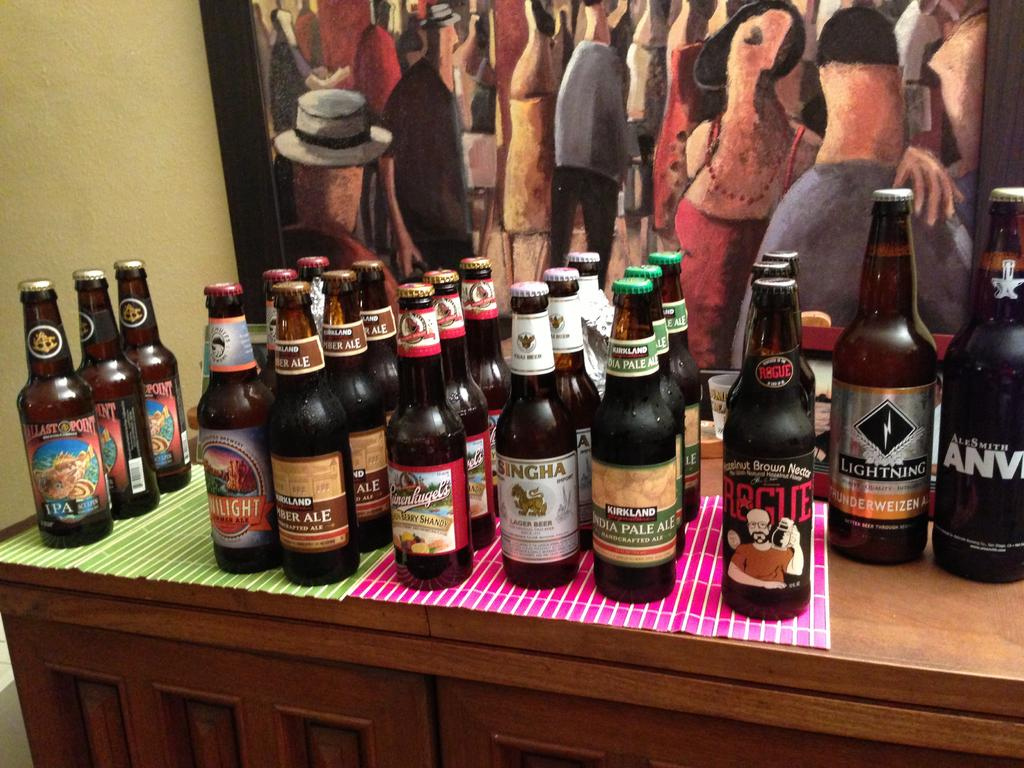<image>
Provide a brief description of the given image. the word kirkland that is on a bottle of beer. 